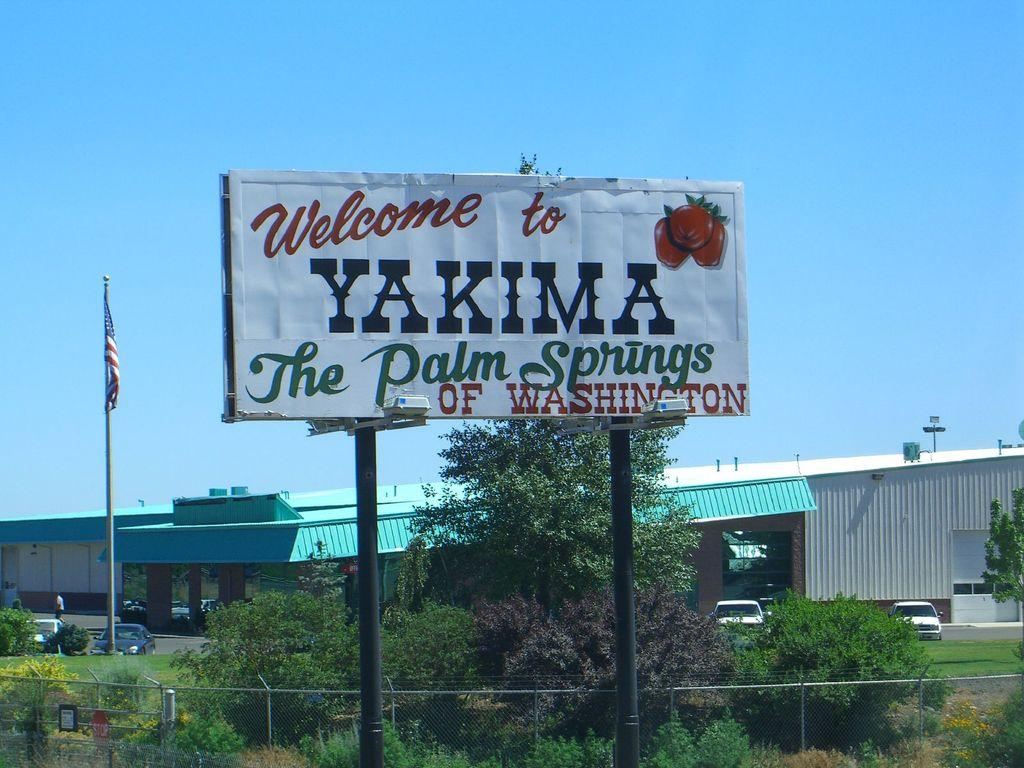<image>
Render a clear and concise summary of the photo. The billboard displays "Welcome to Yakima The Palm Springs of Washington." 